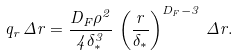<formula> <loc_0><loc_0><loc_500><loc_500>q _ { r } \, \Delta r = \frac { D _ { F } \rho ^ { 2 } } { 4 \delta _ { \ast } ^ { 3 } } \, \left ( \frac { r } { \delta _ { \ast } } \right ) ^ { D _ { F } - 3 } \, \Delta r .</formula> 